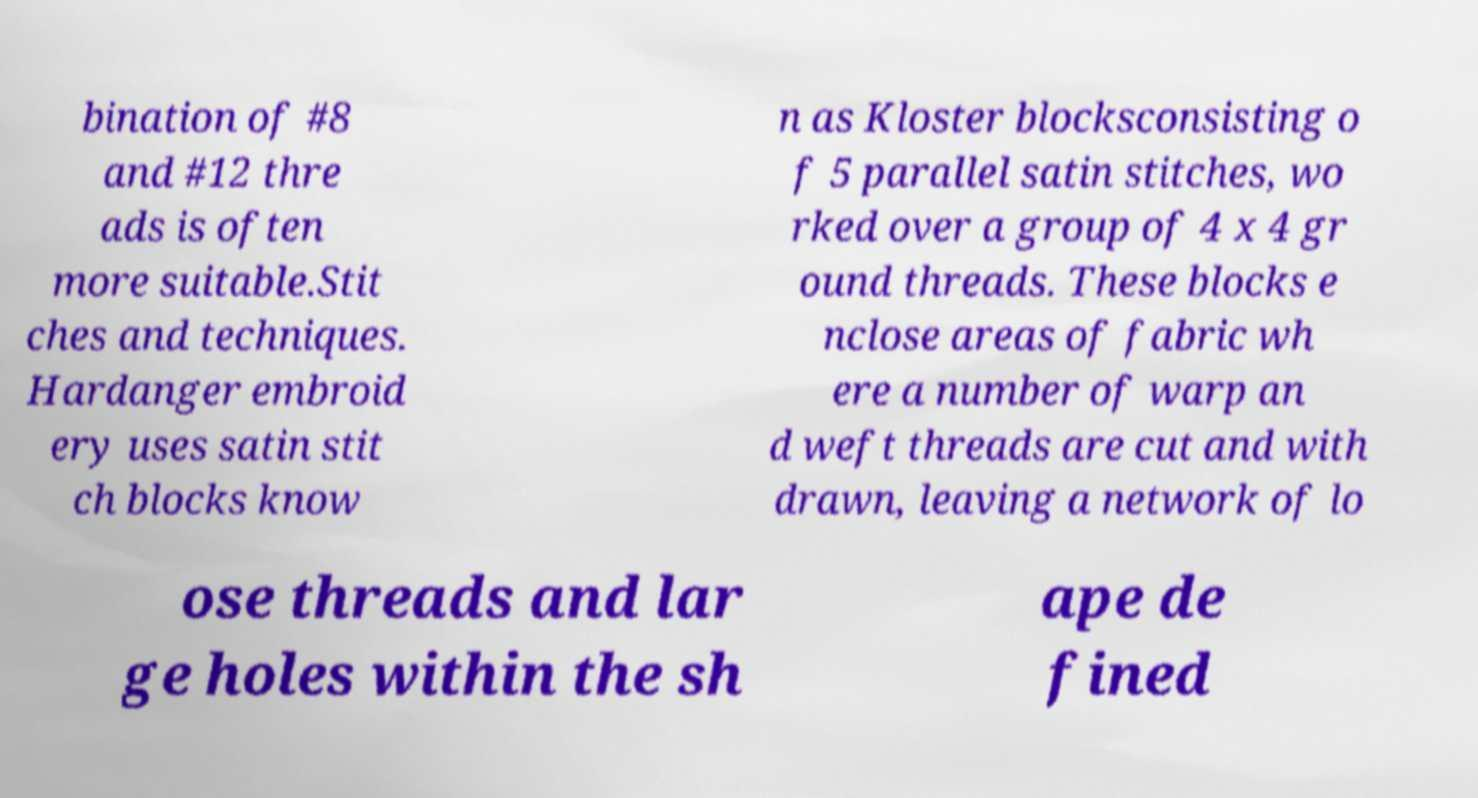Please identify and transcribe the text found in this image. bination of #8 and #12 thre ads is often more suitable.Stit ches and techniques. Hardanger embroid ery uses satin stit ch blocks know n as Kloster blocksconsisting o f 5 parallel satin stitches, wo rked over a group of 4 x 4 gr ound threads. These blocks e nclose areas of fabric wh ere a number of warp an d weft threads are cut and with drawn, leaving a network of lo ose threads and lar ge holes within the sh ape de fined 